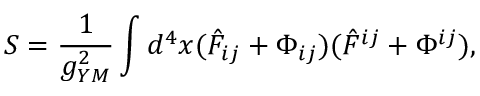<formula> <loc_0><loc_0><loc_500><loc_500>S = \frac { 1 } { g _ { Y M } ^ { 2 } } \int d ^ { 4 } x ( \hat { F } _ { i j } + \Phi _ { i j } ) ( \hat { F } ^ { i j } + \Phi ^ { i j } ) ,</formula> 